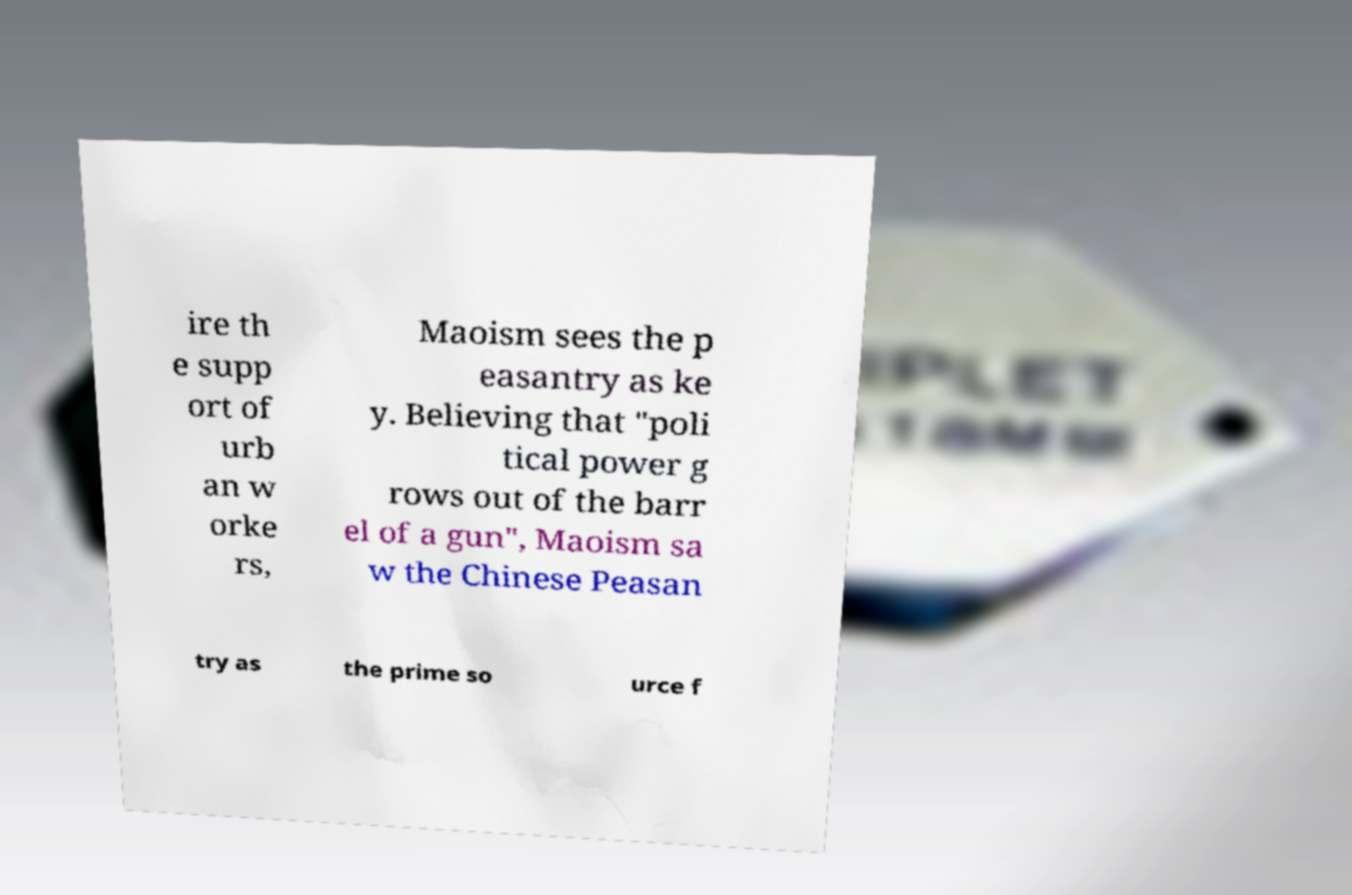What messages or text are displayed in this image? I need them in a readable, typed format. ire th e supp ort of urb an w orke rs, Maoism sees the p easantry as ke y. Believing that "poli tical power g rows out of the barr el of a gun", Maoism sa w the Chinese Peasan try as the prime so urce f 